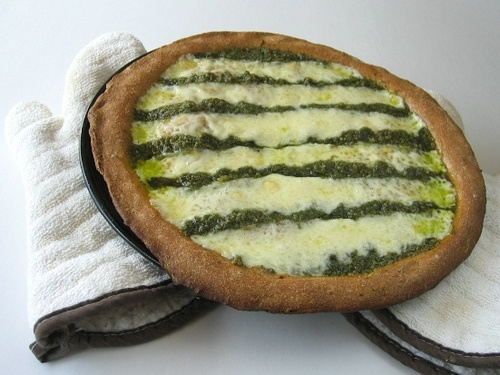Describe the objects in this image and their specific colors. I can see a pizza in white, olive, khaki, and tan tones in this image. 